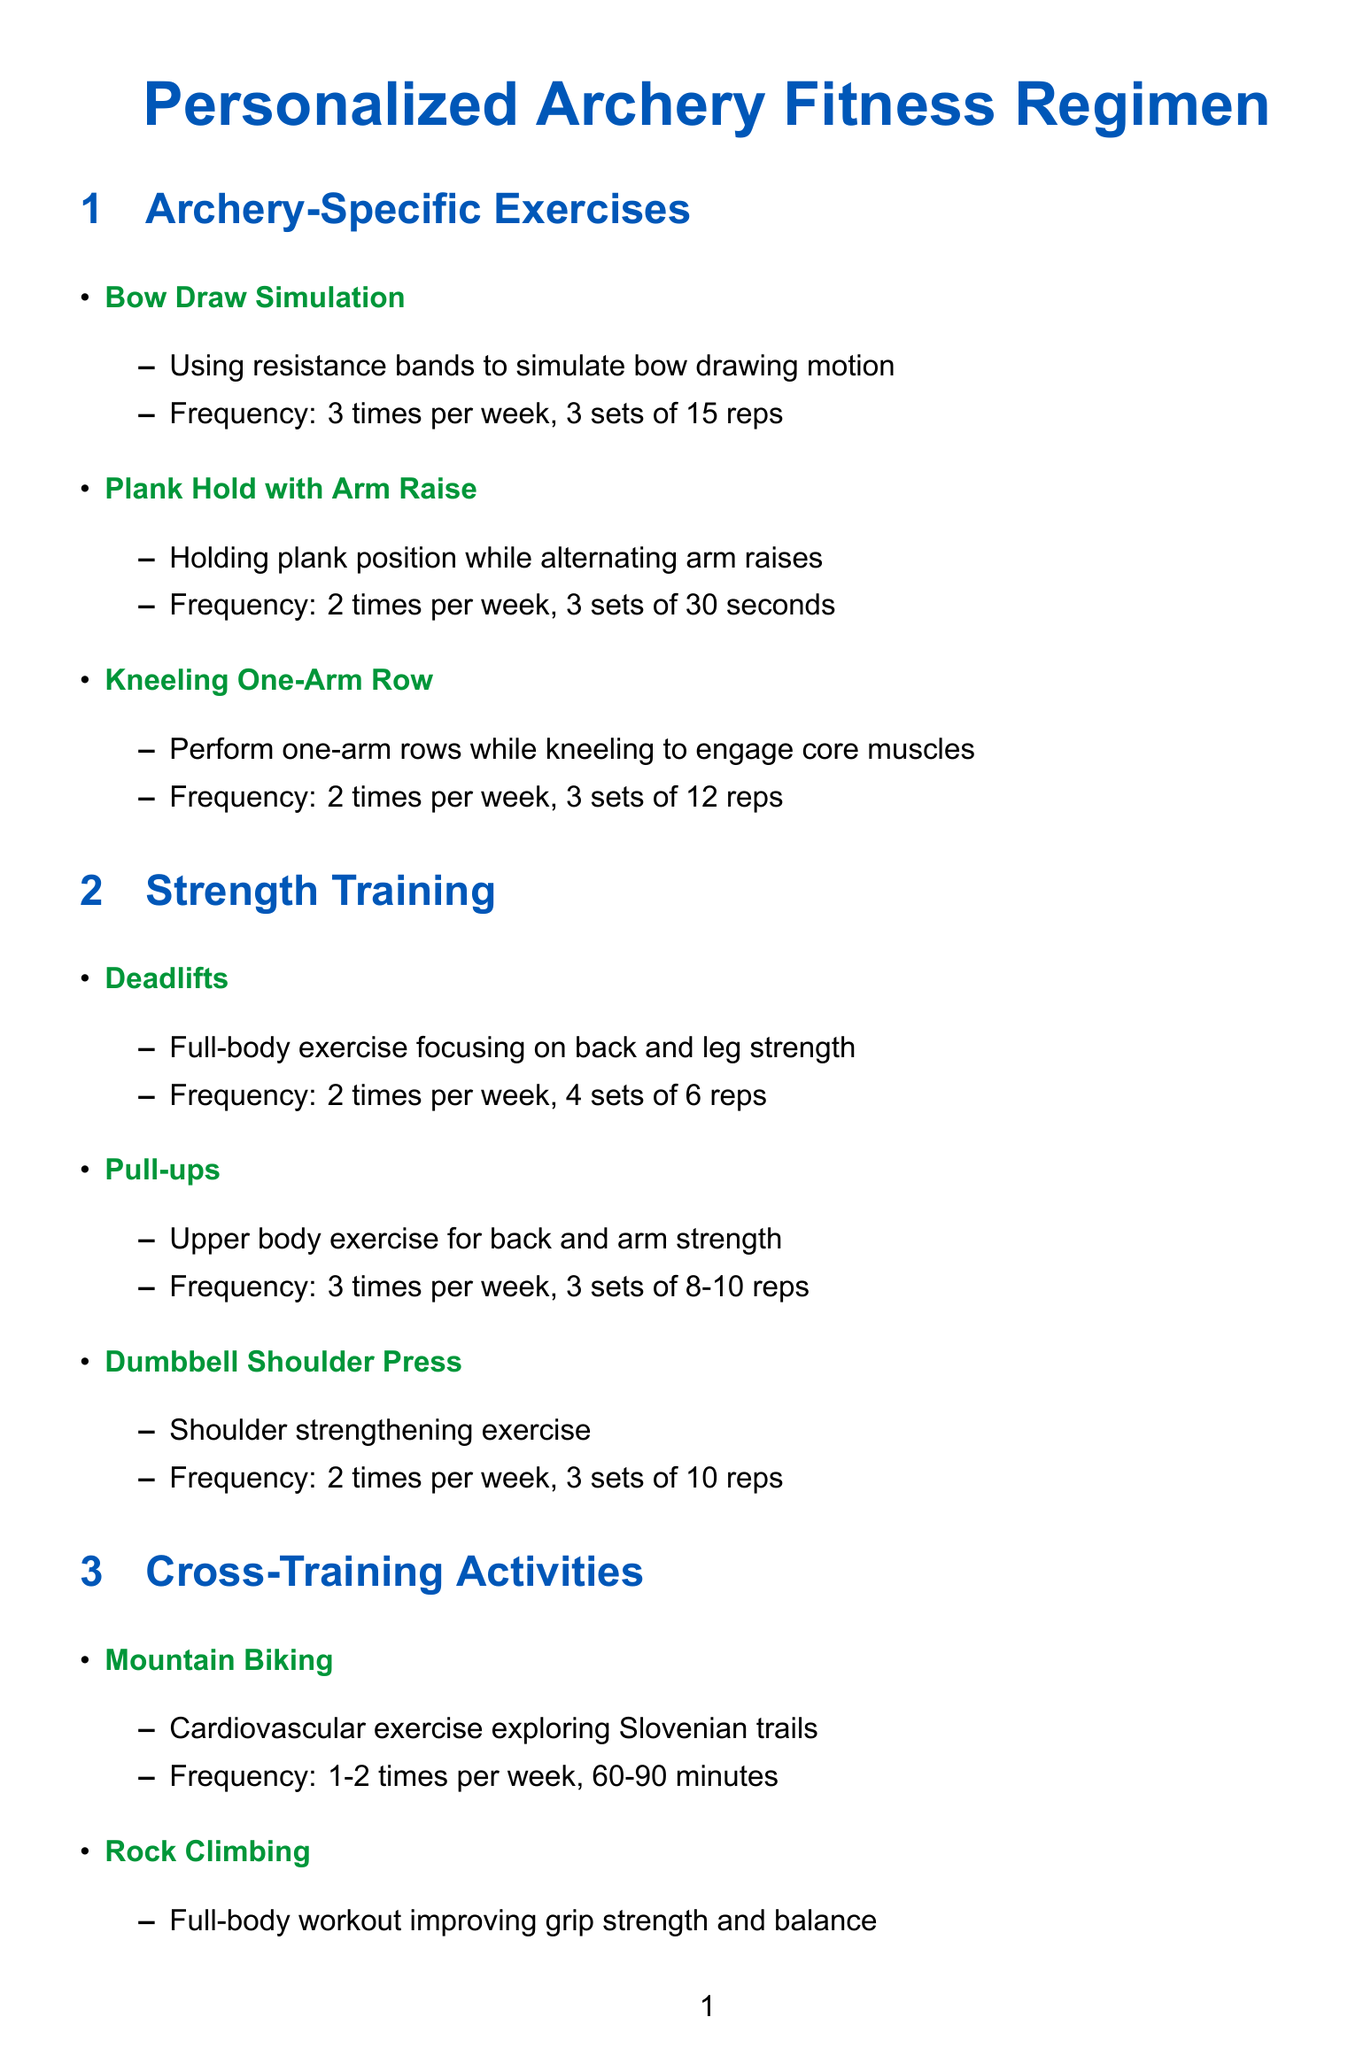What is the frequency of Bow Draw Simulation? The Bow Draw Simulation exercise is performed 3 times per week.
Answer: 3 times per week How many sets are recommended for Pull-ups? The document states that Pull-ups should be done in 3 sets.
Answer: 3 sets What is the duration of Yoga for Archers? Yoga for Archers is recommended for a duration of 30 minutes.
Answer: 30 minutes How often should foam rolling be done? Foam Rolling should be performed 3-4 times per week.
Answer: 3-4 times per week What type of exercise is Rock Climbing categorized as? Rock Climbing is categorized as a cross-training activity.
Answer: Cross-training activity Which local archery club has training sessions on Tuesdays and Thursdays? The Lokostrelski klub Žalec has training sessions on those days.
Answer: Lokostrelski klub Žalec What examples are given for protein-rich meals? Examples provided include Grilled trout, Chicken breast, and Tofu stir-fry.
Answer: Grilled trout, Chicken breast, Tofu stir-fry How many reps are suggested for Dumbbell Shoulder Press? The suggested number of reps for Dumbbell Shoulder Press is 10.
Answer: 10 reps 